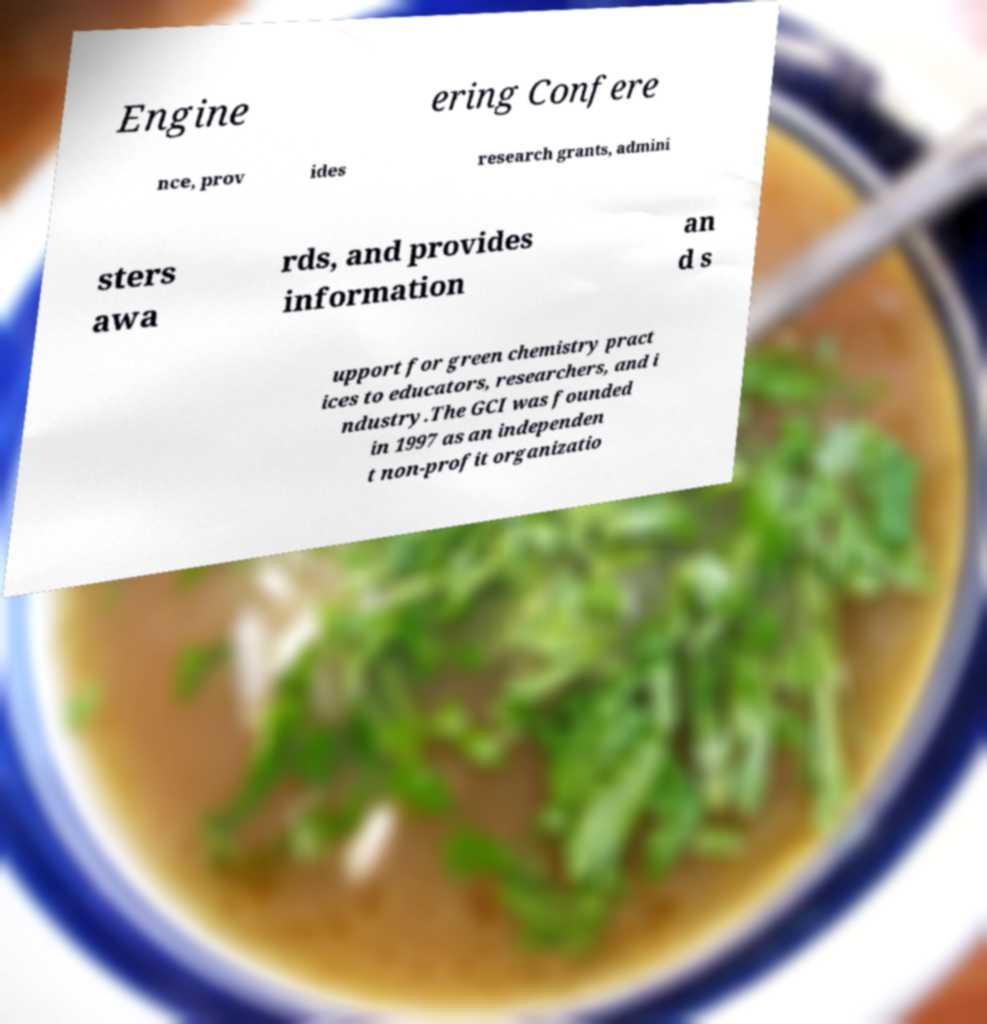Please read and relay the text visible in this image. What does it say? Engine ering Confere nce, prov ides research grants, admini sters awa rds, and provides information an d s upport for green chemistry pract ices to educators, researchers, and i ndustry.The GCI was founded in 1997 as an independen t non-profit organizatio 